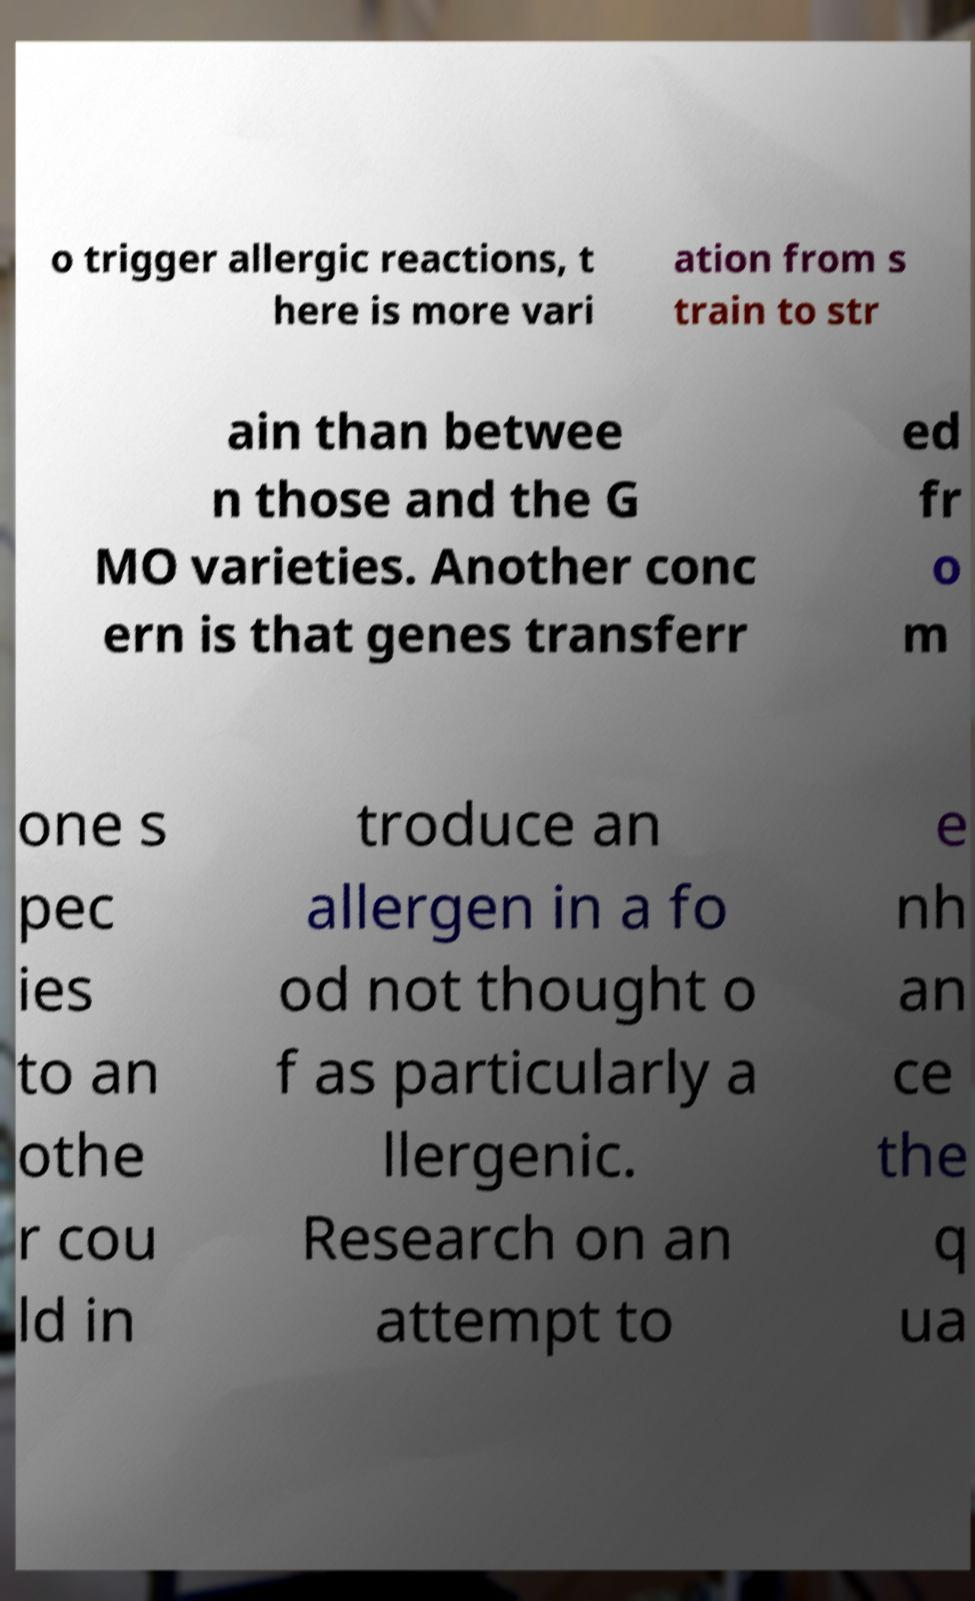Can you read and provide the text displayed in the image?This photo seems to have some interesting text. Can you extract and type it out for me? o trigger allergic reactions, t here is more vari ation from s train to str ain than betwee n those and the G MO varieties. Another conc ern is that genes transferr ed fr o m one s pec ies to an othe r cou ld in troduce an allergen in a fo od not thought o f as particularly a llergenic. Research on an attempt to e nh an ce the q ua 